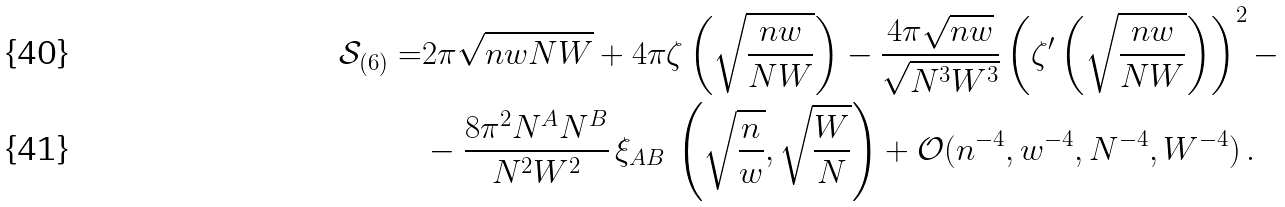<formula> <loc_0><loc_0><loc_500><loc_500>\mathcal { S } _ { ( 6 ) } = & 2 \pi \sqrt { n w N W } + 4 \pi \zeta \left ( \sqrt { \frac { n w } { N W } } \right ) - \frac { 4 \pi \sqrt { n w } } { \sqrt { N ^ { 3 } W ^ { 3 } } } \left ( \zeta ^ { \prime } \left ( \sqrt { \frac { n w } { N W } } \right ) \right ) ^ { 2 } - \\ & - \frac { 8 \pi ^ { 2 } N ^ { A } N ^ { B } } { N ^ { 2 } W ^ { 2 } } \, \xi _ { A B } \, \left ( \sqrt { \frac { n } { w } } , \sqrt { \frac { W } { N } } \right ) + \mathcal { O } ( n ^ { - 4 } , w ^ { - 4 } , N ^ { - 4 } , W ^ { - 4 } ) \, .</formula> 